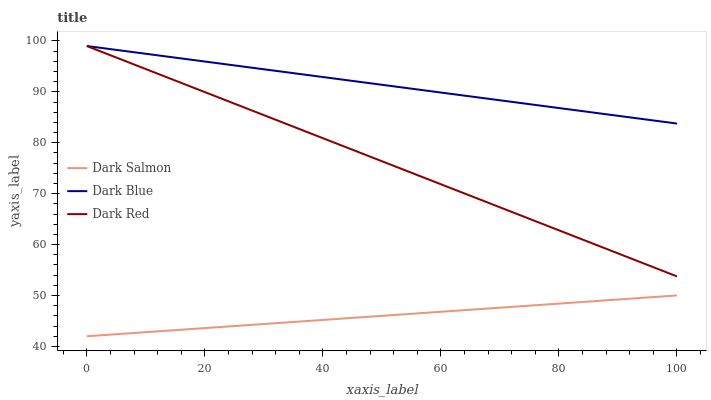Does Dark Salmon have the minimum area under the curve?
Answer yes or no. Yes. Does Dark Blue have the maximum area under the curve?
Answer yes or no. Yes. Does Dark Red have the minimum area under the curve?
Answer yes or no. No. Does Dark Red have the maximum area under the curve?
Answer yes or no. No. Is Dark Salmon the smoothest?
Answer yes or no. Yes. Is Dark Blue the roughest?
Answer yes or no. Yes. Is Dark Red the smoothest?
Answer yes or no. No. Is Dark Red the roughest?
Answer yes or no. No. Does Dark Salmon have the lowest value?
Answer yes or no. Yes. Does Dark Red have the lowest value?
Answer yes or no. No. Does Dark Red have the highest value?
Answer yes or no. Yes. Does Dark Salmon have the highest value?
Answer yes or no. No. Is Dark Salmon less than Dark Blue?
Answer yes or no. Yes. Is Dark Red greater than Dark Salmon?
Answer yes or no. Yes. Does Dark Red intersect Dark Blue?
Answer yes or no. Yes. Is Dark Red less than Dark Blue?
Answer yes or no. No. Is Dark Red greater than Dark Blue?
Answer yes or no. No. Does Dark Salmon intersect Dark Blue?
Answer yes or no. No. 